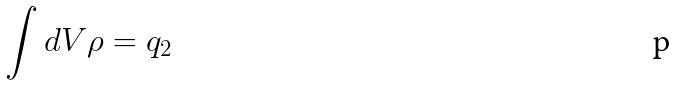<formula> <loc_0><loc_0><loc_500><loc_500>\int d V \rho = q _ { 2 }</formula> 